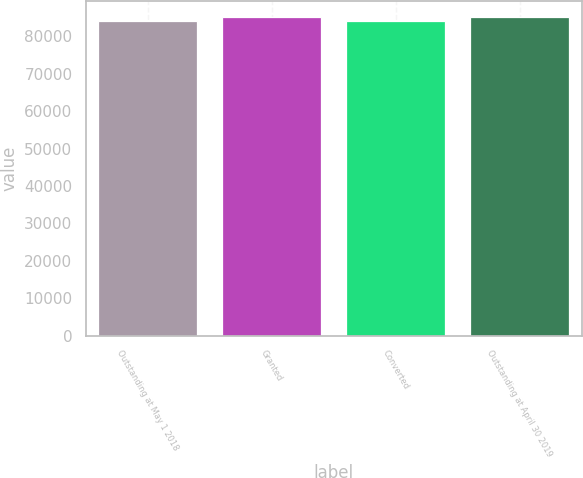Convert chart. <chart><loc_0><loc_0><loc_500><loc_500><bar_chart><fcel>Outstanding at May 1 2018<fcel>Granted<fcel>Converted<fcel>Outstanding at April 30 2019<nl><fcel>84051<fcel>85154<fcel>84161.3<fcel>85264.3<nl></chart> 